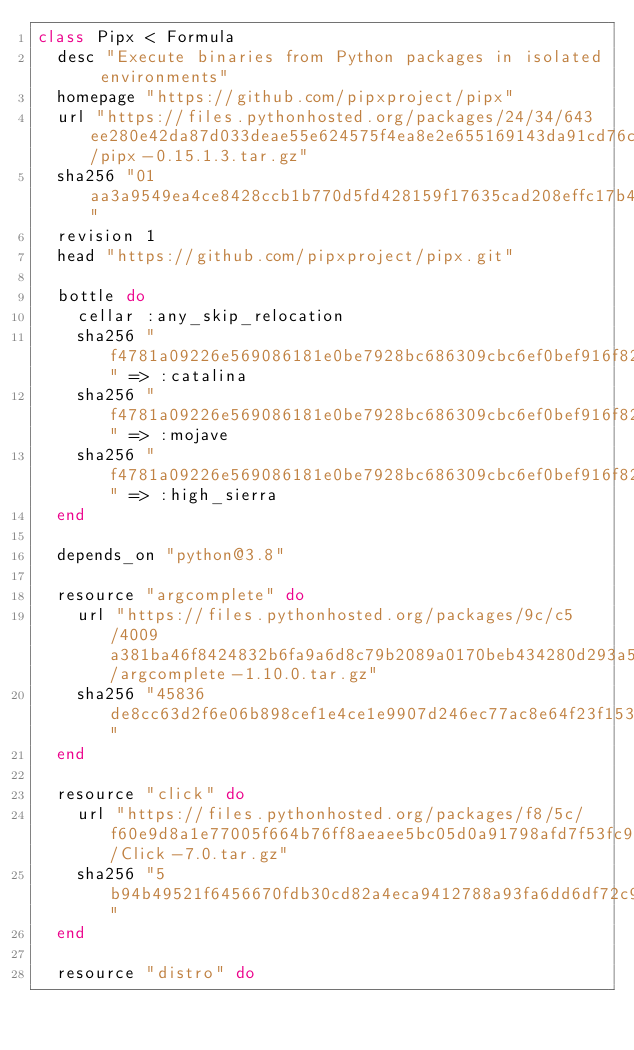<code> <loc_0><loc_0><loc_500><loc_500><_Ruby_>class Pipx < Formula
  desc "Execute binaries from Python packages in isolated environments"
  homepage "https://github.com/pipxproject/pipx"
  url "https://files.pythonhosted.org/packages/24/34/643ee280e42da87d033deae55e624575f4ea8e2e655169143da91cd76c36/pipx-0.15.1.3.tar.gz"
  sha256 "01aa3a9549ea4ce8428ccb1b770d5fd428159f17635cad208effc17b42ccb72e"
  revision 1
  head "https://github.com/pipxproject/pipx.git"

  bottle do
    cellar :any_skip_relocation
    sha256 "f4781a09226e569086181e0be7928bc686309cbc6ef0bef916f829ffe7d71a7a" => :catalina
    sha256 "f4781a09226e569086181e0be7928bc686309cbc6ef0bef916f829ffe7d71a7a" => :mojave
    sha256 "f4781a09226e569086181e0be7928bc686309cbc6ef0bef916f829ffe7d71a7a" => :high_sierra
  end

  depends_on "python@3.8"

  resource "argcomplete" do
    url "https://files.pythonhosted.org/packages/9c/c5/4009a381ba46f8424832b6fa9a6d8c79b2089a0170beb434280d293a5b5c/argcomplete-1.10.0.tar.gz"
    sha256 "45836de8cc63d2f6e06b898cef1e4ce1e9907d246ec77ac8e64f23f153d6bec1"
  end

  resource "click" do
    url "https://files.pythonhosted.org/packages/f8/5c/f60e9d8a1e77005f664b76ff8aeaee5bc05d0a91798afd7f53fc998dbc47/Click-7.0.tar.gz"
    sha256 "5b94b49521f6456670fdb30cd82a4eca9412788a93fa6dd6df72c94d5a8ff2d7"
  end

  resource "distro" do</code> 